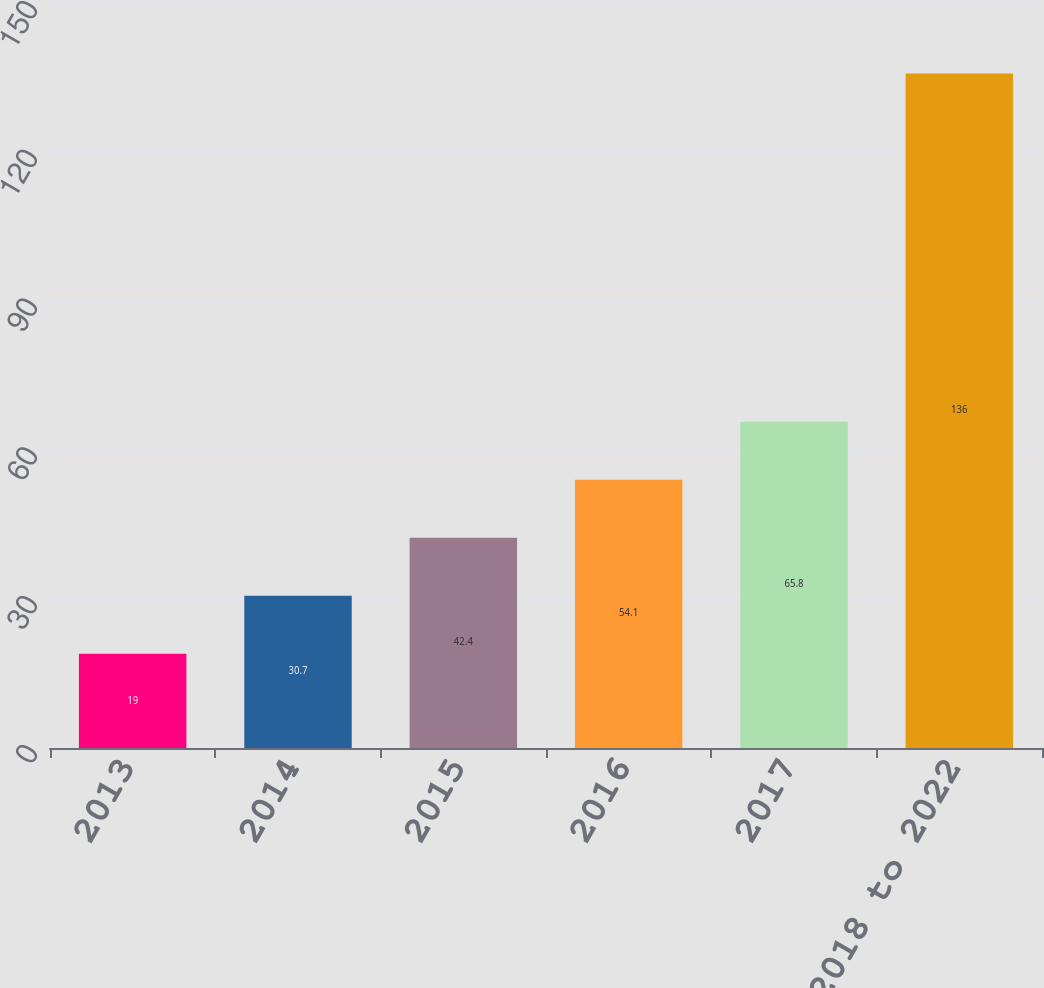Convert chart to OTSL. <chart><loc_0><loc_0><loc_500><loc_500><bar_chart><fcel>2013<fcel>2014<fcel>2015<fcel>2016<fcel>2017<fcel>2018 to 2022<nl><fcel>19<fcel>30.7<fcel>42.4<fcel>54.1<fcel>65.8<fcel>136<nl></chart> 